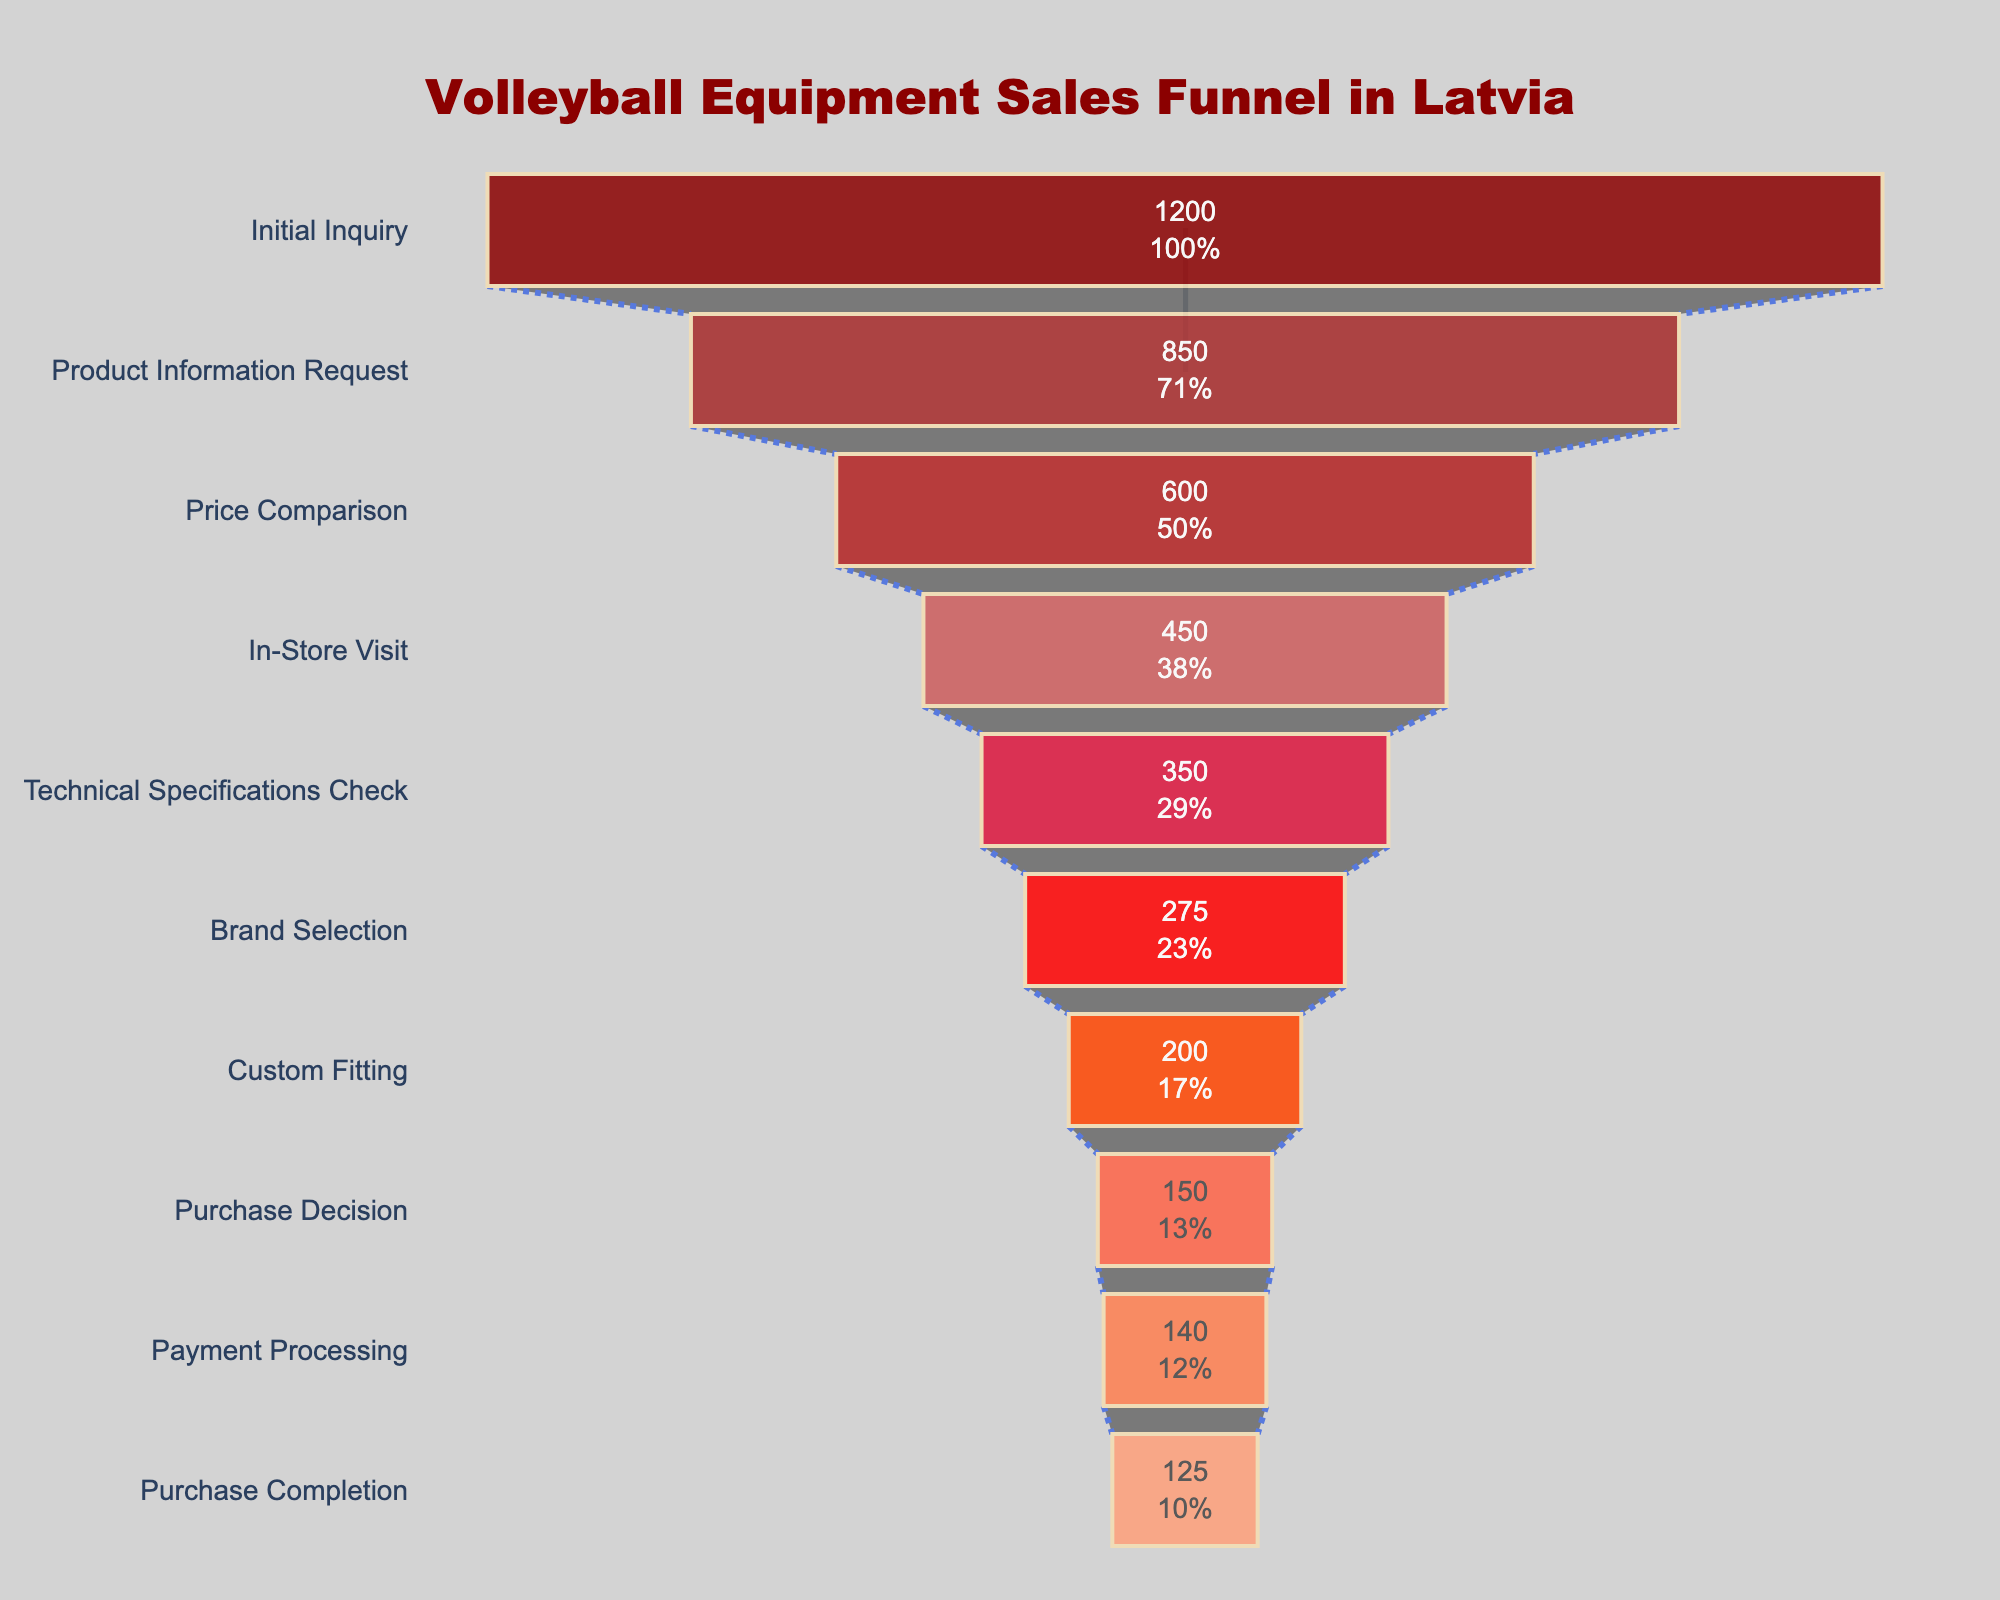What is the title of the funnel chart? The title is the text displayed at the top of the figure, which provides an overview of what the chart represents.
Answer: Volleyball Equipment Sales Funnel in Latvia What is the total number of initial inquiries? The "Initial Inquiry" is the first stage of the funnel chart. You can find the count for this stage directly in the figure.
Answer: 1200 How many stages are there in the sales funnel? Count the number of stages (bars) presented in the funnel chart from top to bottom.
Answer: 10 At which stage do the counts first drop below 500? Look through the counts for each stage and identify the first instance where the count is below 500.
Answer: In-Store Visit What is the percentage loss from the 'Initial Inquiry' to 'Product Information Request' stage? Calculate the difference between the 'Initial Inquiry' (1200) and the 'Product Information Request' (850) counts. Then divide this difference by the 'Initial Inquiry' count and multiply by 100 to find the percentage. Calculation: ((1200 - 850) / 1200) * 100 = 29.17%
Answer: Approximately 29.17% Compare the difference in counts between 'In-Store Visit' and 'Technical Specifications Check' with the difference between 'Brand Selection' and 'Custom Fitting'. For 'In-Store Visit' and 'Technical Specifications Check', the difference is 450 - 350 = 100. For 'Brand Selection' and 'Custom Fitting', the difference is 275 - 200 = 75. The difference between the first pair is larger.
Answer: 100 & 75 What stage has the smallest count? Identify the stage with the smallest value in the funnel chart.
Answer: Purchase Completion By what percentage does the count decrease from 'Purchase Decision' to 'Payment Processing'? Calculate the percentage decrease using the counts from the 'Purchase Decision' (150) and 'Payment Processing' (140) stages. Percentage decrease: ((150 - 140) / 150) * 100 = 6.67%.
Answer: Approximately 6.67% How many more purchases are completed compared to the number of custom fittings? Subtract the count of the 'Custom Fitting' stage (200) from the 'Purchase Completion' stage (125). 200 - 125 = 75, so there are 75 fewer purchases completed.
Answer: 75 fewer Is the drop from 'Custom Fitting' to 'Purchase Decision' larger or smaller than the drop from 'Product Information Request' to 'Price Comparison'? The drop from 'Custom Fitting' (200) to 'Purchase Decision' (150) is 50. The drop from 'Product Information Request' (850) to 'Price Comparison' (600) is 250. The drop from 'Product Information Request' to 'Price Comparison' is larger.
Answer: Larger 